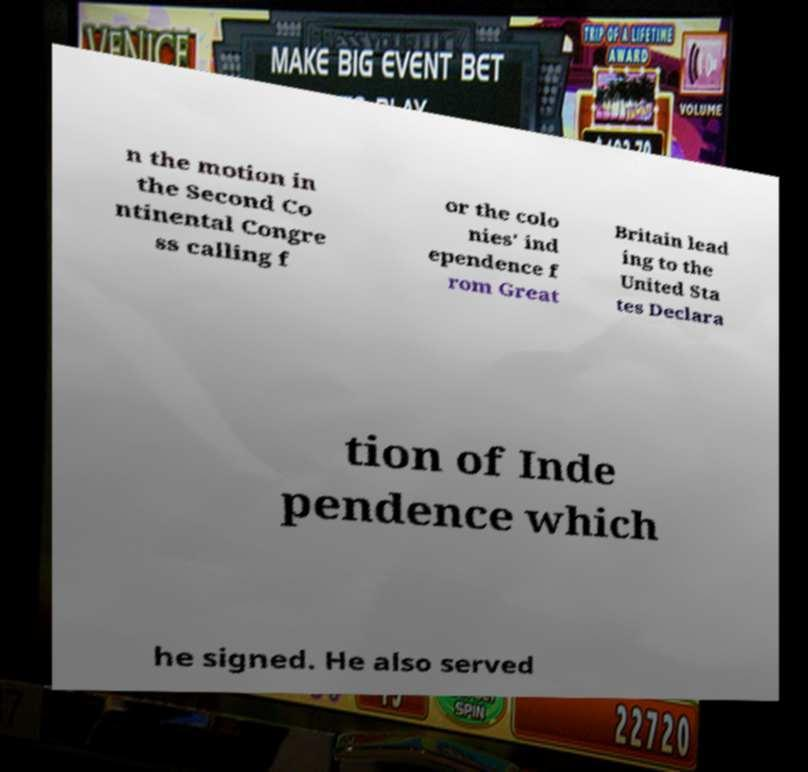Please read and relay the text visible in this image. What does it say? n the motion in the Second Co ntinental Congre ss calling f or the colo nies' ind ependence f rom Great Britain lead ing to the United Sta tes Declara tion of Inde pendence which he signed. He also served 